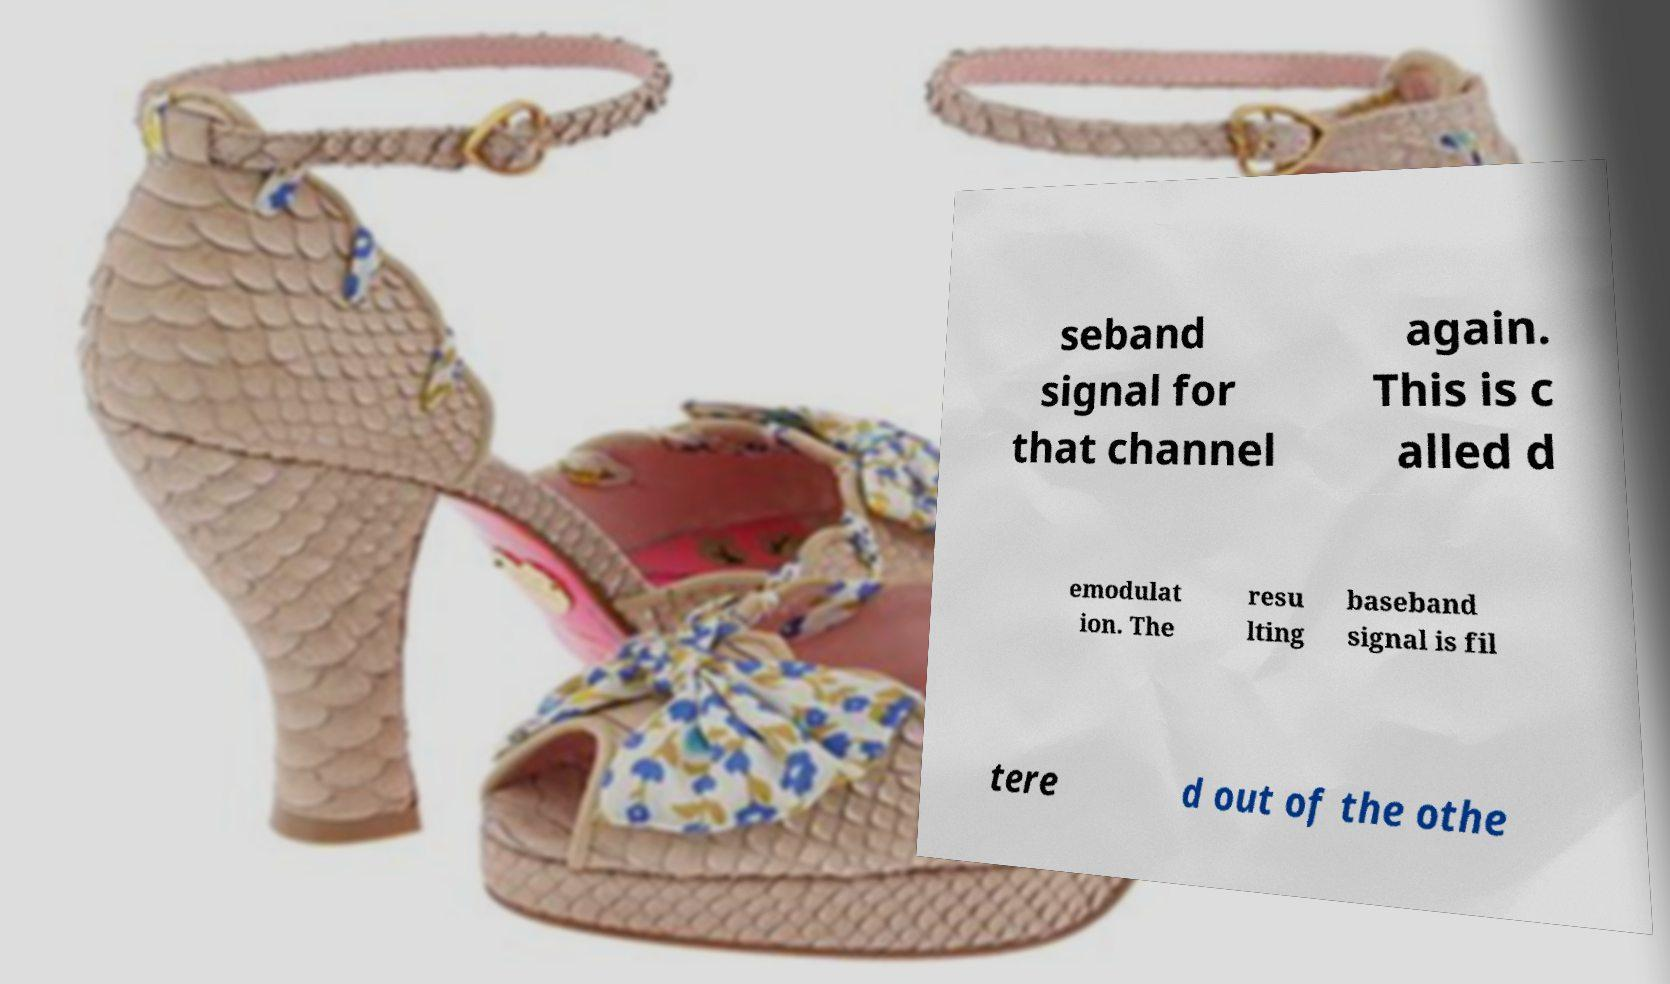Can you accurately transcribe the text from the provided image for me? seband signal for that channel again. This is c alled d emodulat ion. The resu lting baseband signal is fil tere d out of the othe 